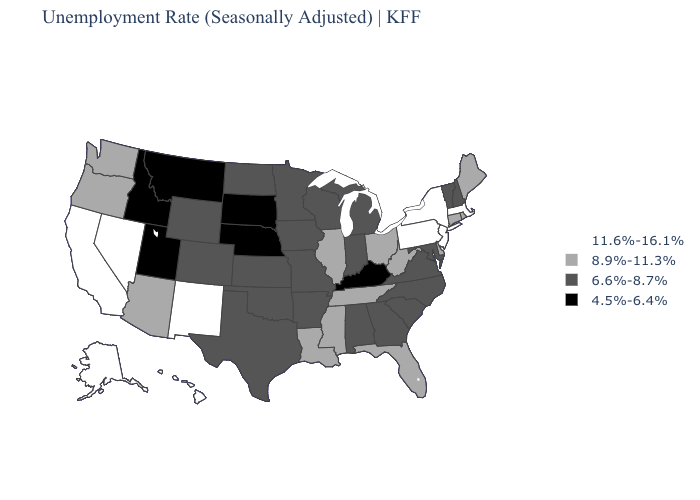What is the value of Florida?
Quick response, please. 8.9%-11.3%. What is the value of Wisconsin?
Write a very short answer. 6.6%-8.7%. Which states have the highest value in the USA?
Write a very short answer. Alaska, California, Hawaii, Massachusetts, Nevada, New Jersey, New Mexico, New York, Pennsylvania. Does Nebraska have the lowest value in the MidWest?
Keep it brief. Yes. What is the highest value in the South ?
Give a very brief answer. 8.9%-11.3%. What is the value of Louisiana?
Keep it brief. 8.9%-11.3%. Does Arkansas have the highest value in the South?
Write a very short answer. No. Which states have the lowest value in the MidWest?
Keep it brief. Nebraska, South Dakota. Does Nebraska have the lowest value in the MidWest?
Short answer required. Yes. Name the states that have a value in the range 8.9%-11.3%?
Write a very short answer. Arizona, Connecticut, Delaware, Florida, Illinois, Louisiana, Maine, Mississippi, Ohio, Oregon, Rhode Island, Tennessee, Washington, West Virginia. Is the legend a continuous bar?
Short answer required. No. Does the first symbol in the legend represent the smallest category?
Quick response, please. No. What is the highest value in the South ?
Write a very short answer. 8.9%-11.3%. Name the states that have a value in the range 6.6%-8.7%?
Write a very short answer. Alabama, Arkansas, Colorado, Georgia, Indiana, Iowa, Kansas, Maryland, Michigan, Minnesota, Missouri, New Hampshire, North Carolina, North Dakota, Oklahoma, South Carolina, Texas, Vermont, Virginia, Wisconsin, Wyoming. Does the first symbol in the legend represent the smallest category?
Keep it brief. No. 